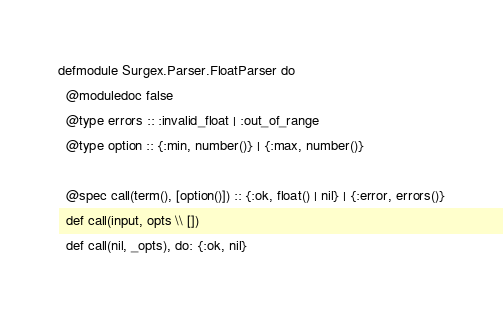<code> <loc_0><loc_0><loc_500><loc_500><_Elixir_>defmodule Surgex.Parser.FloatParser do
  @moduledoc false
  @type errors :: :invalid_float | :out_of_range
  @type option :: {:min, number()} | {:max, number()}

  @spec call(term(), [option()]) :: {:ok, float() | nil} | {:error, errors()}
  def call(input, opts \\ [])
  def call(nil, _opts), do: {:ok, nil}</code> 